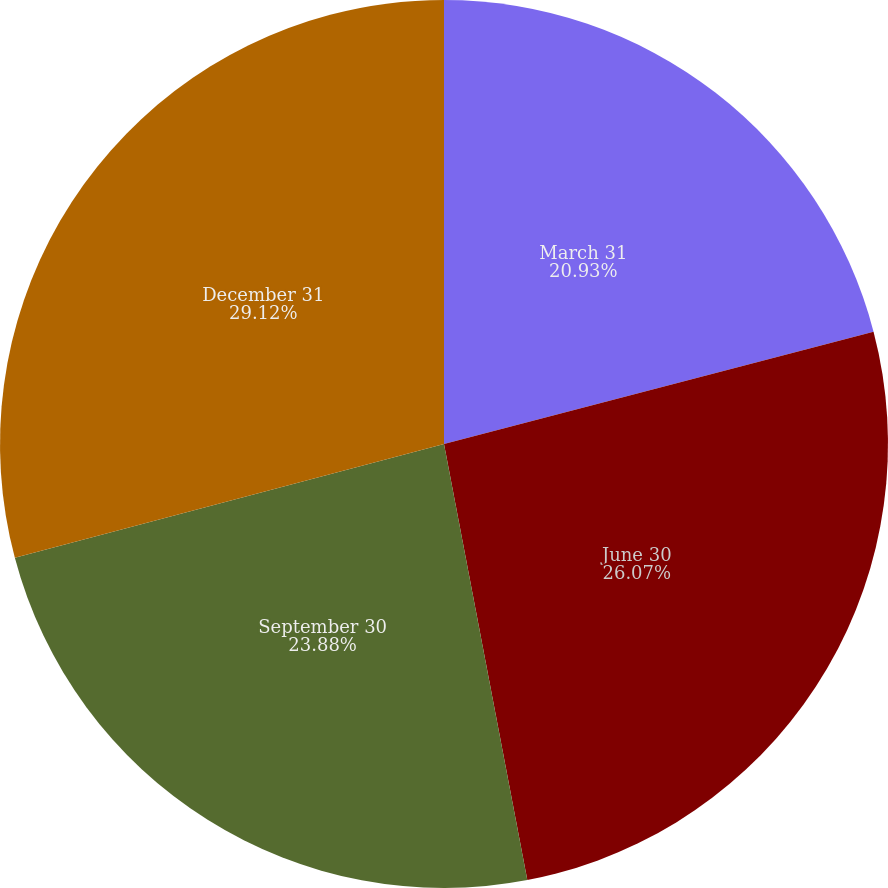Convert chart to OTSL. <chart><loc_0><loc_0><loc_500><loc_500><pie_chart><fcel>March 31<fcel>June 30<fcel>September 30<fcel>December 31<nl><fcel>20.93%<fcel>26.07%<fcel>23.88%<fcel>29.13%<nl></chart> 